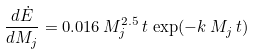Convert formula to latex. <formula><loc_0><loc_0><loc_500><loc_500>\frac { d \dot { E } } { d M _ { j } } = 0 . 0 1 6 \, M _ { j } ^ { 2 . 5 } \, t \, \exp ( - k \, M _ { j } \, t )</formula> 